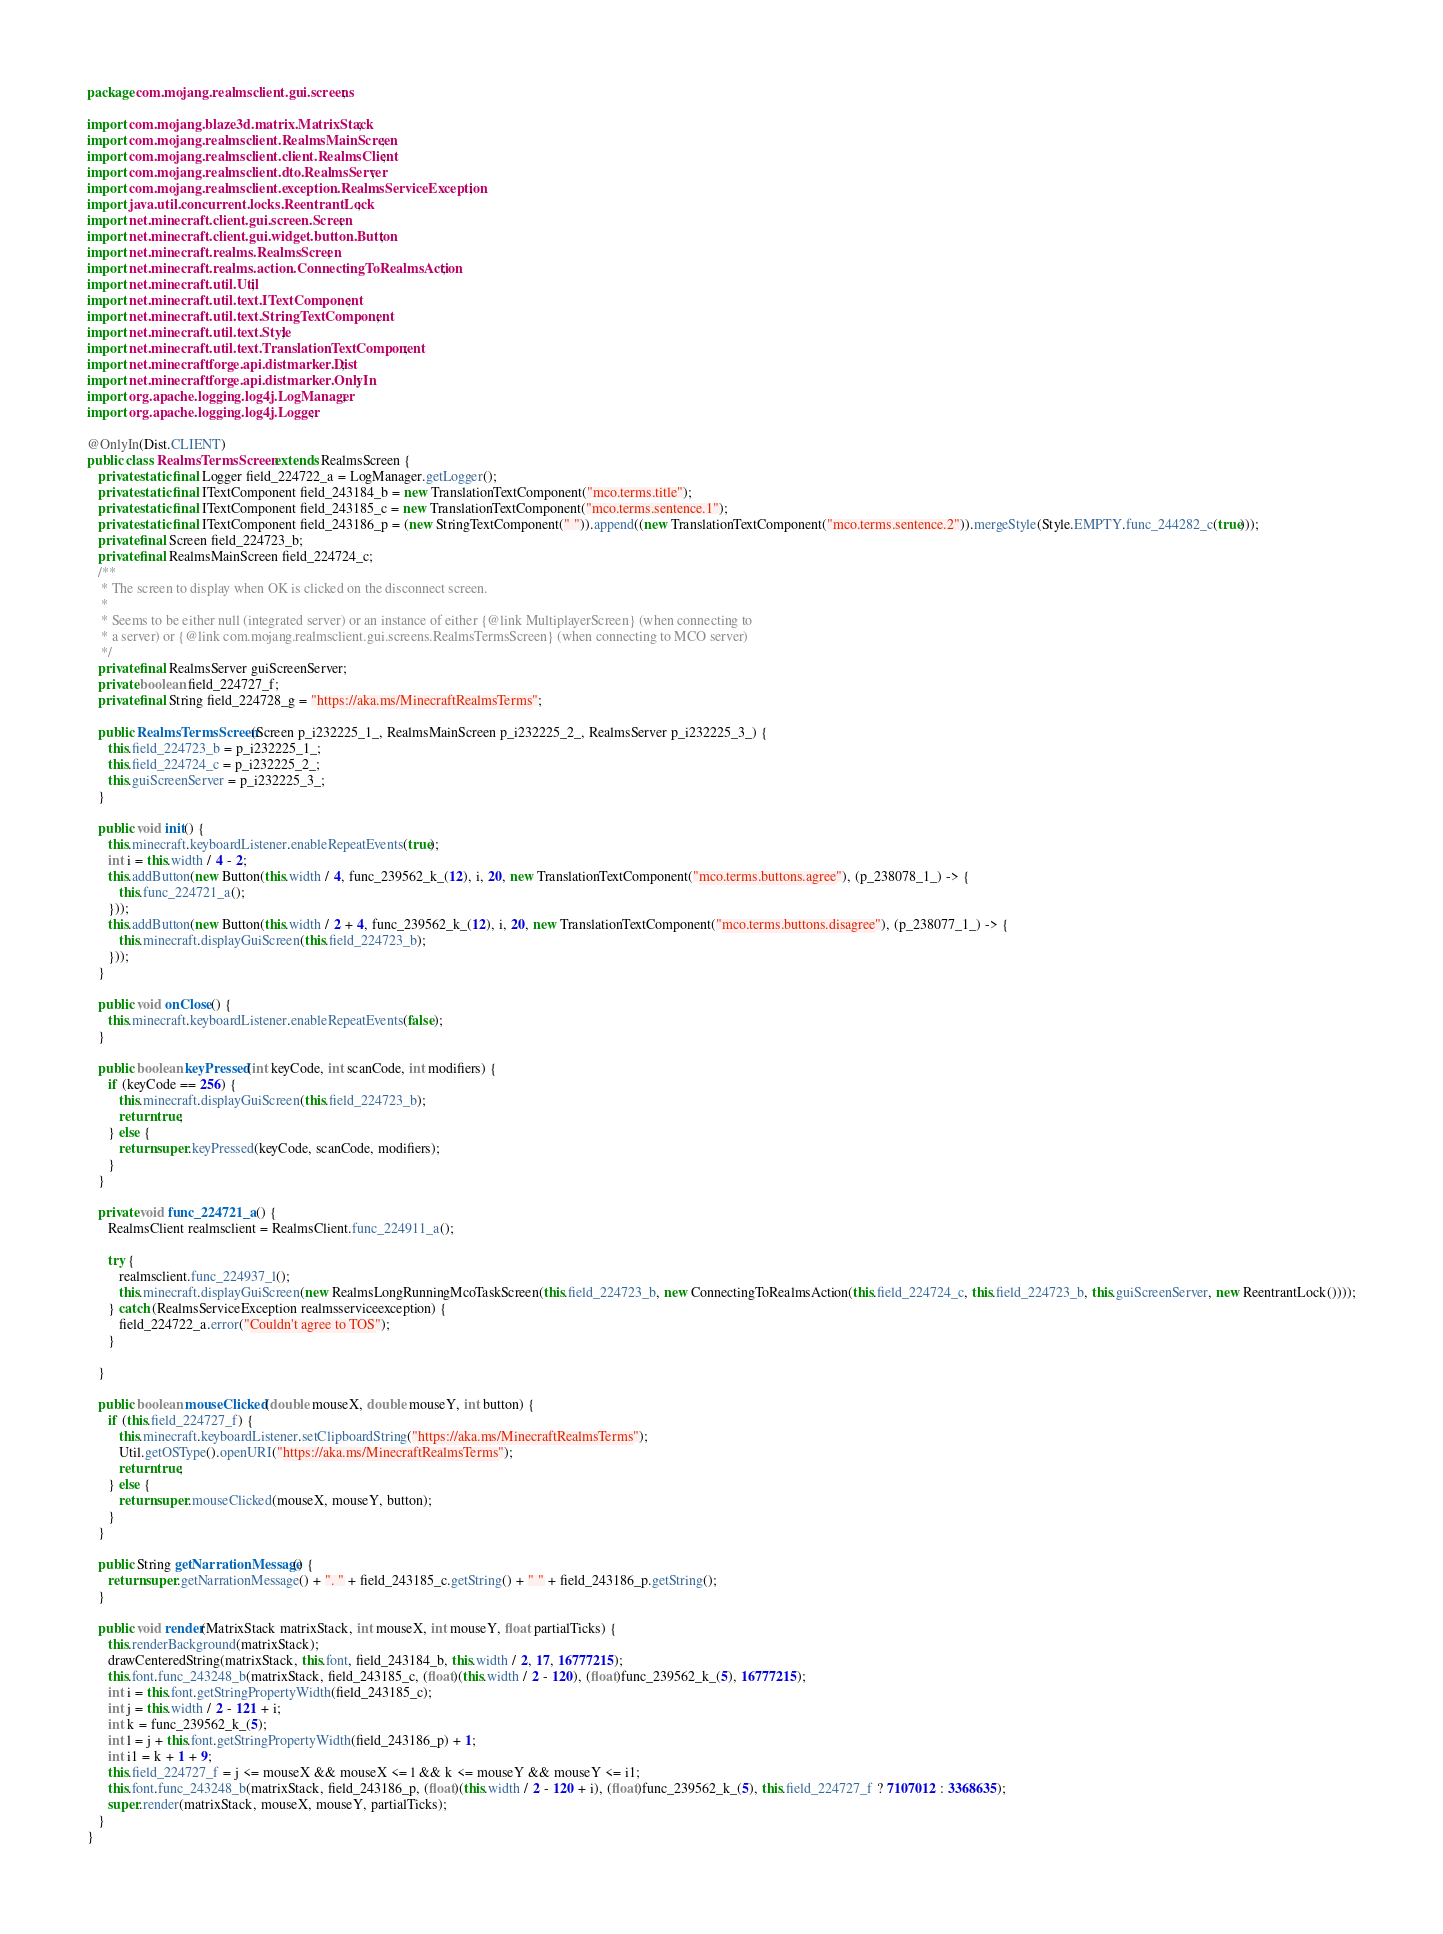Convert code to text. <code><loc_0><loc_0><loc_500><loc_500><_Java_>package com.mojang.realmsclient.gui.screens;

import com.mojang.blaze3d.matrix.MatrixStack;
import com.mojang.realmsclient.RealmsMainScreen;
import com.mojang.realmsclient.client.RealmsClient;
import com.mojang.realmsclient.dto.RealmsServer;
import com.mojang.realmsclient.exception.RealmsServiceException;
import java.util.concurrent.locks.ReentrantLock;
import net.minecraft.client.gui.screen.Screen;
import net.minecraft.client.gui.widget.button.Button;
import net.minecraft.realms.RealmsScreen;
import net.minecraft.realms.action.ConnectingToRealmsAction;
import net.minecraft.util.Util;
import net.minecraft.util.text.ITextComponent;
import net.minecraft.util.text.StringTextComponent;
import net.minecraft.util.text.Style;
import net.minecraft.util.text.TranslationTextComponent;
import net.minecraftforge.api.distmarker.Dist;
import net.minecraftforge.api.distmarker.OnlyIn;
import org.apache.logging.log4j.LogManager;
import org.apache.logging.log4j.Logger;

@OnlyIn(Dist.CLIENT)
public class RealmsTermsScreen extends RealmsScreen {
   private static final Logger field_224722_a = LogManager.getLogger();
   private static final ITextComponent field_243184_b = new TranslationTextComponent("mco.terms.title");
   private static final ITextComponent field_243185_c = new TranslationTextComponent("mco.terms.sentence.1");
   private static final ITextComponent field_243186_p = (new StringTextComponent(" ")).append((new TranslationTextComponent("mco.terms.sentence.2")).mergeStyle(Style.EMPTY.func_244282_c(true)));
   private final Screen field_224723_b;
   private final RealmsMainScreen field_224724_c;
   /**
    * The screen to display when OK is clicked on the disconnect screen.
    *  
    * Seems to be either null (integrated server) or an instance of either {@link MultiplayerScreen} (when connecting to
    * a server) or {@link com.mojang.realmsclient.gui.screens.RealmsTermsScreen} (when connecting to MCO server)
    */
   private final RealmsServer guiScreenServer;
   private boolean field_224727_f;
   private final String field_224728_g = "https://aka.ms/MinecraftRealmsTerms";

   public RealmsTermsScreen(Screen p_i232225_1_, RealmsMainScreen p_i232225_2_, RealmsServer p_i232225_3_) {
      this.field_224723_b = p_i232225_1_;
      this.field_224724_c = p_i232225_2_;
      this.guiScreenServer = p_i232225_3_;
   }

   public void init() {
      this.minecraft.keyboardListener.enableRepeatEvents(true);
      int i = this.width / 4 - 2;
      this.addButton(new Button(this.width / 4, func_239562_k_(12), i, 20, new TranslationTextComponent("mco.terms.buttons.agree"), (p_238078_1_) -> {
         this.func_224721_a();
      }));
      this.addButton(new Button(this.width / 2 + 4, func_239562_k_(12), i, 20, new TranslationTextComponent("mco.terms.buttons.disagree"), (p_238077_1_) -> {
         this.minecraft.displayGuiScreen(this.field_224723_b);
      }));
   }

   public void onClose() {
      this.minecraft.keyboardListener.enableRepeatEvents(false);
   }

   public boolean keyPressed(int keyCode, int scanCode, int modifiers) {
      if (keyCode == 256) {
         this.minecraft.displayGuiScreen(this.field_224723_b);
         return true;
      } else {
         return super.keyPressed(keyCode, scanCode, modifiers);
      }
   }

   private void func_224721_a() {
      RealmsClient realmsclient = RealmsClient.func_224911_a();

      try {
         realmsclient.func_224937_l();
         this.minecraft.displayGuiScreen(new RealmsLongRunningMcoTaskScreen(this.field_224723_b, new ConnectingToRealmsAction(this.field_224724_c, this.field_224723_b, this.guiScreenServer, new ReentrantLock())));
      } catch (RealmsServiceException realmsserviceexception) {
         field_224722_a.error("Couldn't agree to TOS");
      }

   }

   public boolean mouseClicked(double mouseX, double mouseY, int button) {
      if (this.field_224727_f) {
         this.minecraft.keyboardListener.setClipboardString("https://aka.ms/MinecraftRealmsTerms");
         Util.getOSType().openURI("https://aka.ms/MinecraftRealmsTerms");
         return true;
      } else {
         return super.mouseClicked(mouseX, mouseY, button);
      }
   }

   public String getNarrationMessage() {
      return super.getNarrationMessage() + ". " + field_243185_c.getString() + " " + field_243186_p.getString();
   }

   public void render(MatrixStack matrixStack, int mouseX, int mouseY, float partialTicks) {
      this.renderBackground(matrixStack);
      drawCenteredString(matrixStack, this.font, field_243184_b, this.width / 2, 17, 16777215);
      this.font.func_243248_b(matrixStack, field_243185_c, (float)(this.width / 2 - 120), (float)func_239562_k_(5), 16777215);
      int i = this.font.getStringPropertyWidth(field_243185_c);
      int j = this.width / 2 - 121 + i;
      int k = func_239562_k_(5);
      int l = j + this.font.getStringPropertyWidth(field_243186_p) + 1;
      int i1 = k + 1 + 9;
      this.field_224727_f = j <= mouseX && mouseX <= l && k <= mouseY && mouseY <= i1;
      this.font.func_243248_b(matrixStack, field_243186_p, (float)(this.width / 2 - 120 + i), (float)func_239562_k_(5), this.field_224727_f ? 7107012 : 3368635);
      super.render(matrixStack, mouseX, mouseY, partialTicks);
   }
}
</code> 